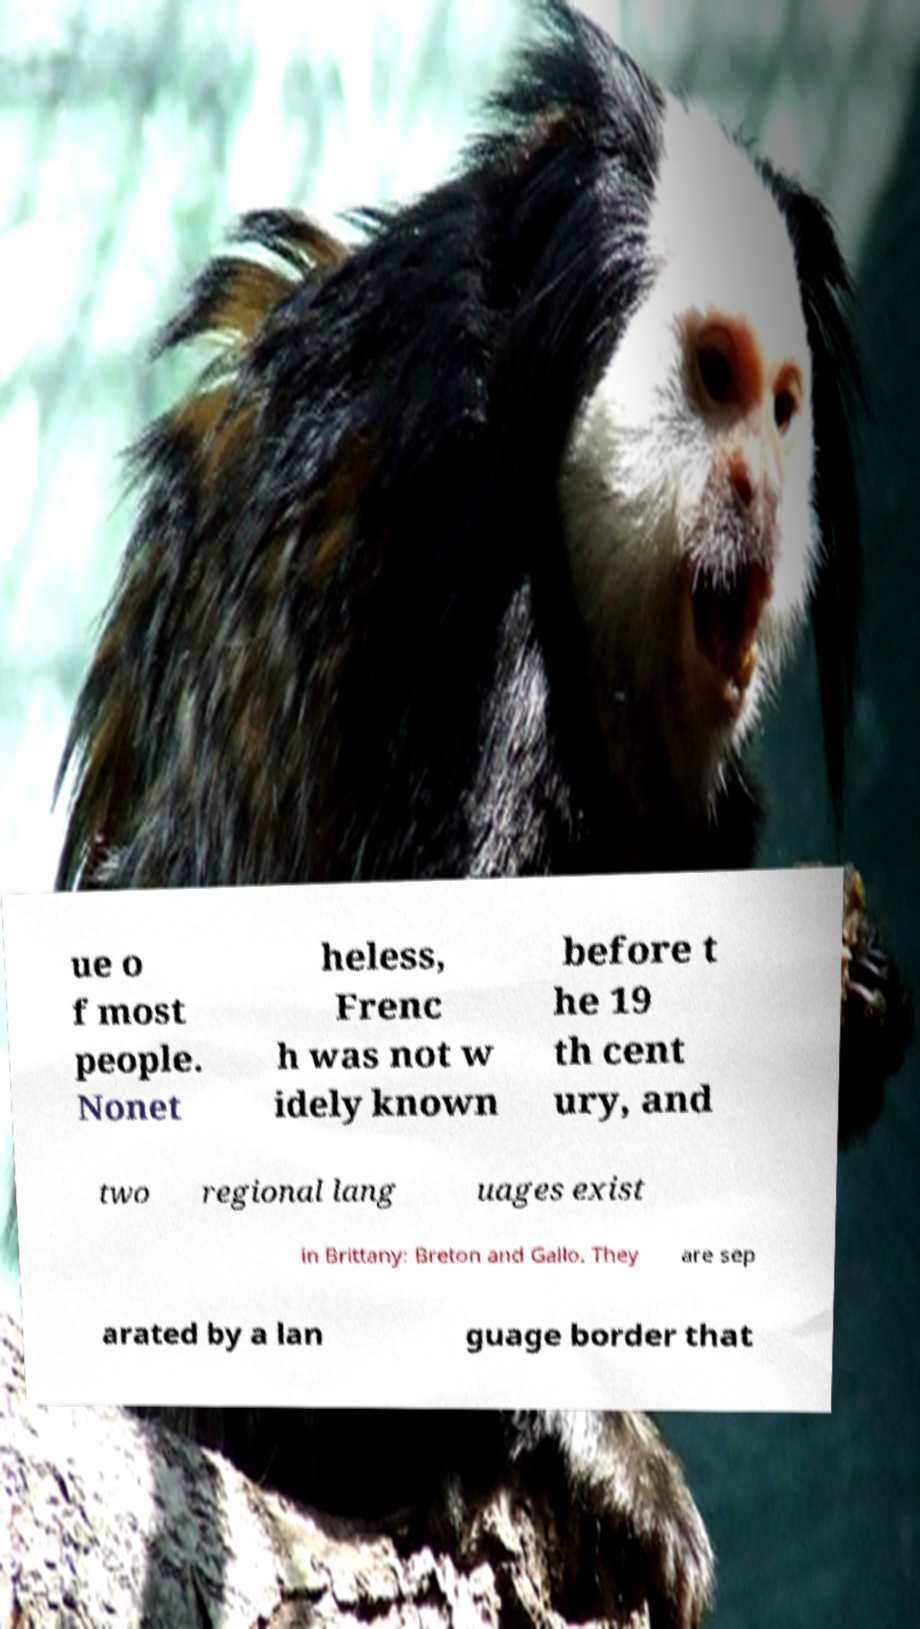I need the written content from this picture converted into text. Can you do that? ue o f most people. Nonet heless, Frenc h was not w idely known before t he 19 th cent ury, and two regional lang uages exist in Brittany: Breton and Gallo. They are sep arated by a lan guage border that 